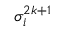Convert formula to latex. <formula><loc_0><loc_0><loc_500><loc_500>\sigma _ { i } ^ { 2 k + 1 }</formula> 